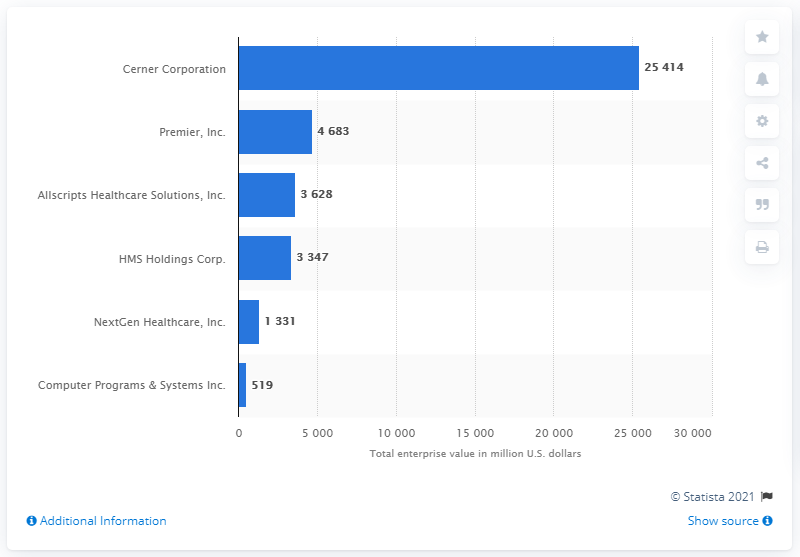Indicate a few pertinent items in this graphic. On January 31, 2021, the enterprise value of Cerner Corporation was 25,414. 